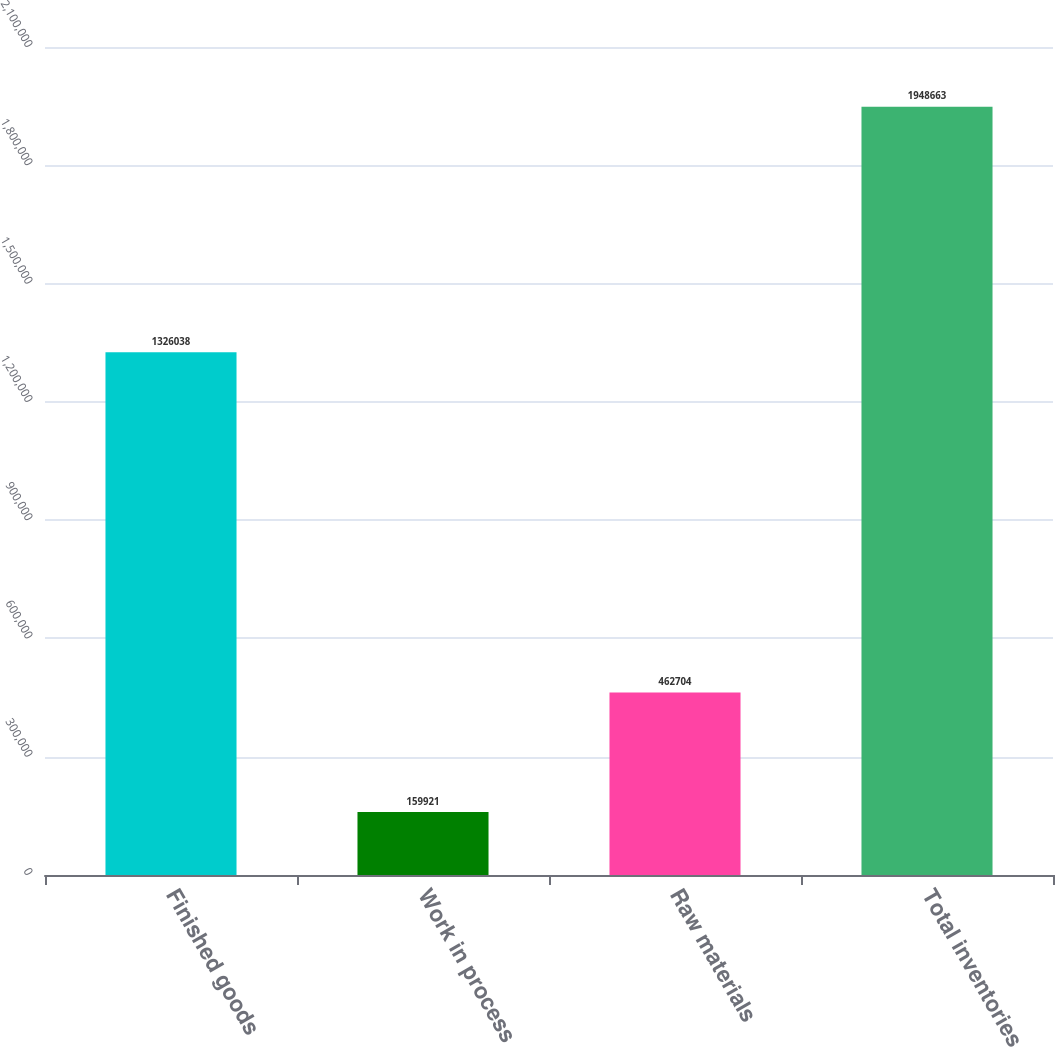<chart> <loc_0><loc_0><loc_500><loc_500><bar_chart><fcel>Finished goods<fcel>Work in process<fcel>Raw materials<fcel>Total inventories<nl><fcel>1.32604e+06<fcel>159921<fcel>462704<fcel>1.94866e+06<nl></chart> 